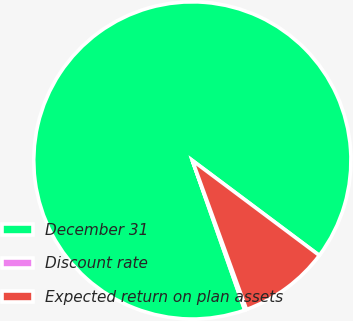Convert chart. <chart><loc_0><loc_0><loc_500><loc_500><pie_chart><fcel>December 31<fcel>Discount rate<fcel>Expected return on plan assets<nl><fcel>90.59%<fcel>0.19%<fcel>9.23%<nl></chart> 